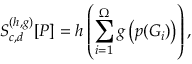Convert formula to latex. <formula><loc_0><loc_0><loc_500><loc_500>S _ { c , d } ^ { ( h , g ) } [ P ] = h \left ( \sum _ { i = 1 } ^ { \Omega } g \left ( p ( G _ { i } ) \right ) \right ) ,</formula> 